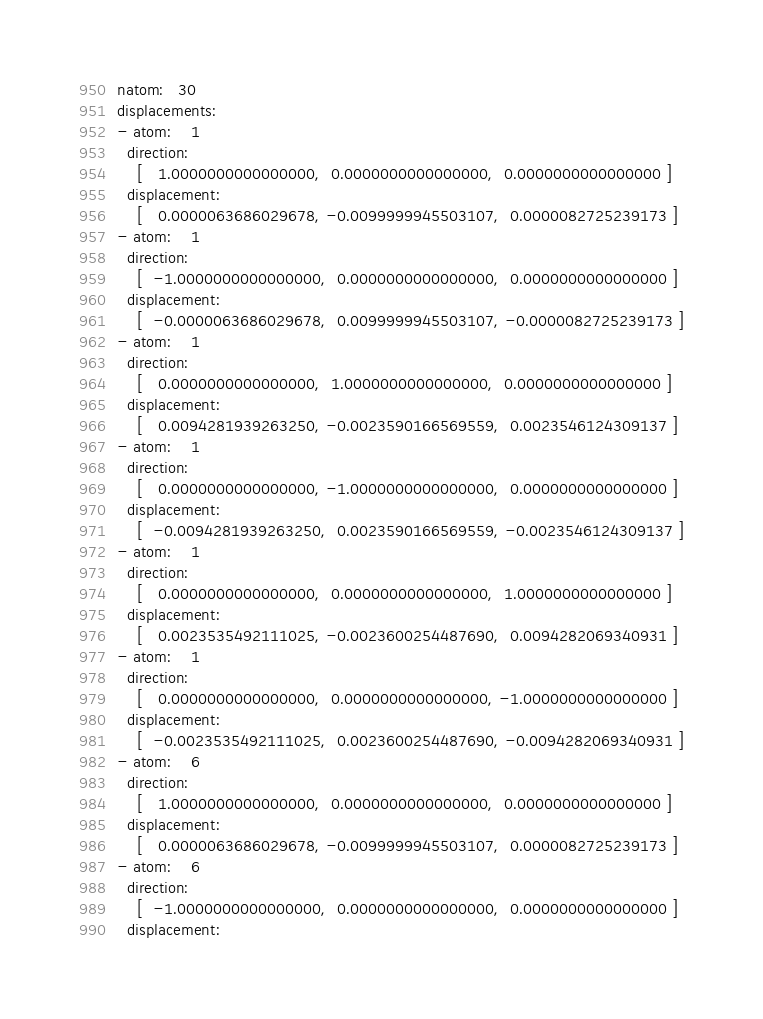<code> <loc_0><loc_0><loc_500><loc_500><_YAML_>natom:   30
displacements:
- atom:    1
  direction:
    [   1.0000000000000000,  0.0000000000000000,  0.0000000000000000 ]
  displacement:
    [   0.0000063686029678, -0.0099999945503107,  0.0000082725239173 ]
- atom:    1
  direction:
    [  -1.0000000000000000,  0.0000000000000000,  0.0000000000000000 ]
  displacement:
    [  -0.0000063686029678,  0.0099999945503107, -0.0000082725239173 ]
- atom:    1
  direction:
    [   0.0000000000000000,  1.0000000000000000,  0.0000000000000000 ]
  displacement:
    [   0.0094281939263250, -0.0023590166569559,  0.0023546124309137 ]
- atom:    1
  direction:
    [   0.0000000000000000, -1.0000000000000000,  0.0000000000000000 ]
  displacement:
    [  -0.0094281939263250,  0.0023590166569559, -0.0023546124309137 ]
- atom:    1
  direction:
    [   0.0000000000000000,  0.0000000000000000,  1.0000000000000000 ]
  displacement:
    [   0.0023535492111025, -0.0023600254487690,  0.0094282069340931 ]
- atom:    1
  direction:
    [   0.0000000000000000,  0.0000000000000000, -1.0000000000000000 ]
  displacement:
    [  -0.0023535492111025,  0.0023600254487690, -0.0094282069340931 ]
- atom:    6
  direction:
    [   1.0000000000000000,  0.0000000000000000,  0.0000000000000000 ]
  displacement:
    [   0.0000063686029678, -0.0099999945503107,  0.0000082725239173 ]
- atom:    6
  direction:
    [  -1.0000000000000000,  0.0000000000000000,  0.0000000000000000 ]
  displacement:</code> 